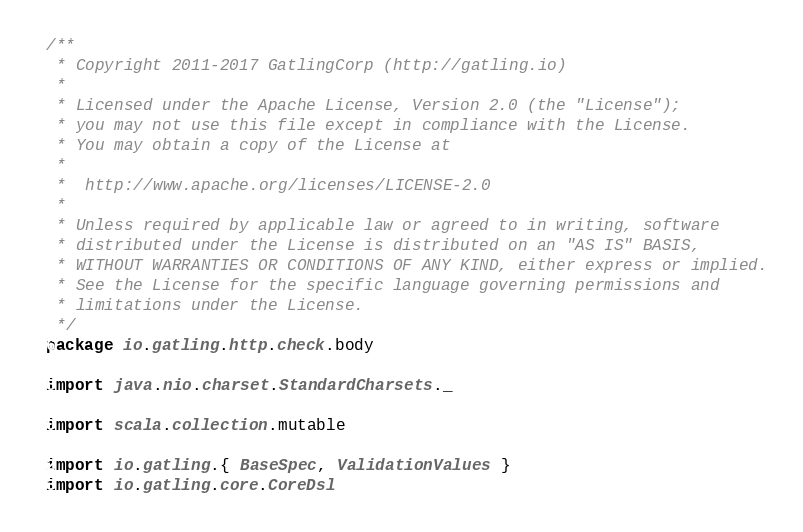<code> <loc_0><loc_0><loc_500><loc_500><_Scala_>/**
 * Copyright 2011-2017 GatlingCorp (http://gatling.io)
 *
 * Licensed under the Apache License, Version 2.0 (the "License");
 * you may not use this file except in compliance with the License.
 * You may obtain a copy of the License at
 *
 *  http://www.apache.org/licenses/LICENSE-2.0
 *
 * Unless required by applicable law or agreed to in writing, software
 * distributed under the License is distributed on an "AS IS" BASIS,
 * WITHOUT WARRANTIES OR CONDITIONS OF ANY KIND, either express or implied.
 * See the License for the specific language governing permissions and
 * limitations under the License.
 */
package io.gatling.http.check.body

import java.nio.charset.StandardCharsets._

import scala.collection.mutable

import io.gatling.{ BaseSpec, ValidationValues }
import io.gatling.core.CoreDsl</code> 